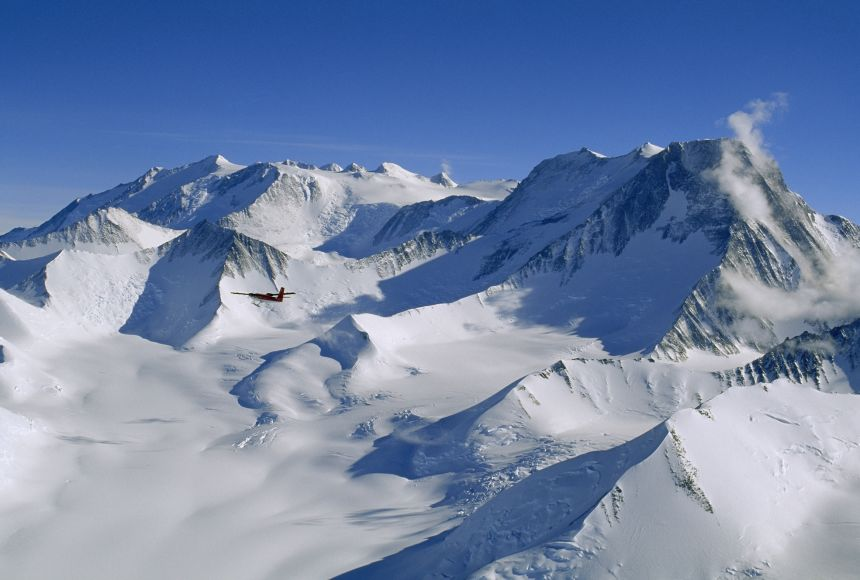Can you explain why the snow appears blue in some areas of the mountains? The snow appears blue in some areas due to the way deep snow absorbs and scatters light. Blue light penetrates snow more deeply than other colors and gets scattered, causing the snow in thick, dense patches to appear blue. This is particularly visible in glacial ice and deeply compacted snow areas, where the layers are clean and clear, allowing the blue light's effects to be more pronounced. 